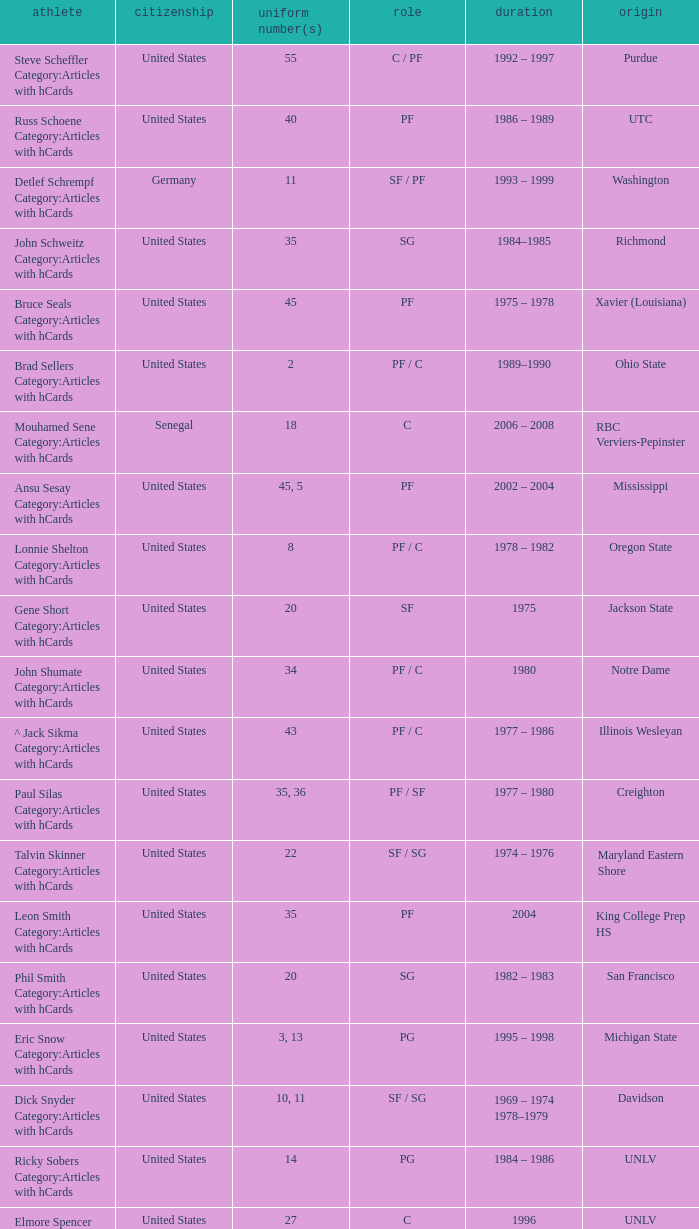Would you be able to parse every entry in this table? {'header': ['athlete', 'citizenship', 'uniform number(s)', 'role', 'duration', 'origin'], 'rows': [['Steve Scheffler Category:Articles with hCards', 'United States', '55', 'C / PF', '1992 – 1997', 'Purdue'], ['Russ Schoene Category:Articles with hCards', 'United States', '40', 'PF', '1986 – 1989', 'UTC'], ['Detlef Schrempf Category:Articles with hCards', 'Germany', '11', 'SF / PF', '1993 – 1999', 'Washington'], ['John Schweitz Category:Articles with hCards', 'United States', '35', 'SG', '1984–1985', 'Richmond'], ['Bruce Seals Category:Articles with hCards', 'United States', '45', 'PF', '1975 – 1978', 'Xavier (Louisiana)'], ['Brad Sellers Category:Articles with hCards', 'United States', '2', 'PF / C', '1989–1990', 'Ohio State'], ['Mouhamed Sene Category:Articles with hCards', 'Senegal', '18', 'C', '2006 – 2008', 'RBC Verviers-Pepinster'], ['Ansu Sesay Category:Articles with hCards', 'United States', '45, 5', 'PF', '2002 – 2004', 'Mississippi'], ['Lonnie Shelton Category:Articles with hCards', 'United States', '8', 'PF / C', '1978 – 1982', 'Oregon State'], ['Gene Short Category:Articles with hCards', 'United States', '20', 'SF', '1975', 'Jackson State'], ['John Shumate Category:Articles with hCards', 'United States', '34', 'PF / C', '1980', 'Notre Dame'], ['^ Jack Sikma Category:Articles with hCards', 'United States', '43', 'PF / C', '1977 – 1986', 'Illinois Wesleyan'], ['Paul Silas Category:Articles with hCards', 'United States', '35, 36', 'PF / SF', '1977 – 1980', 'Creighton'], ['Talvin Skinner Category:Articles with hCards', 'United States', '22', 'SF / SG', '1974 – 1976', 'Maryland Eastern Shore'], ['Leon Smith Category:Articles with hCards', 'United States', '35', 'PF', '2004', 'King College Prep HS'], ['Phil Smith Category:Articles with hCards', 'United States', '20', 'SG', '1982 – 1983', 'San Francisco'], ['Eric Snow Category:Articles with hCards', 'United States', '3, 13', 'PG', '1995 – 1998', 'Michigan State'], ['Dick Snyder Category:Articles with hCards', 'United States', '10, 11', 'SF / SG', '1969 – 1974 1978–1979', 'Davidson'], ['Ricky Sobers Category:Articles with hCards', 'United States', '14', 'PG', '1984 – 1986', 'UNLV'], ['Elmore Spencer Category:Articles with hCards', 'United States', '27', 'C', '1996', 'UNLV'], ['Isaac Stallworth Category:Articles with hCards', 'United States', '15', 'SF / SG', '1972 – 1974', 'Kansas'], ['Terence Stansbury Category:Articles with hCards', 'United States', '44', 'SG', '1986–1987', 'Temple'], ['Vladimir Stepania Category:Articles with hCards', 'Georgia', '5', 'Center', '1999 – 2000', 'KK Union Olimpija'], ['Larry Stewart Category:Articles with hCards', 'United States', '23', 'SF', '1996–1997', 'Coppin State'], ['Alex Stivrins Category:Articles with hCards', 'United States', '42', 'PF', '1985', 'Colorado'], ['Jon Sundvold Category:Articles with hCards', 'United States', '20', 'SG', '1984 – 1985', 'Missouri'], ['Robert Swift Category:Articles with hCards', 'United States', '31', 'C', '2005 – 2008', 'Bakersfield HS'], ['Wally Szczerbiak Category:Articles with hCards', 'United States', '3', 'SF / SG', '2007–2008', 'Miami (Ohio)']]} What position does the player with jersey number 22 play? SF / SG. 